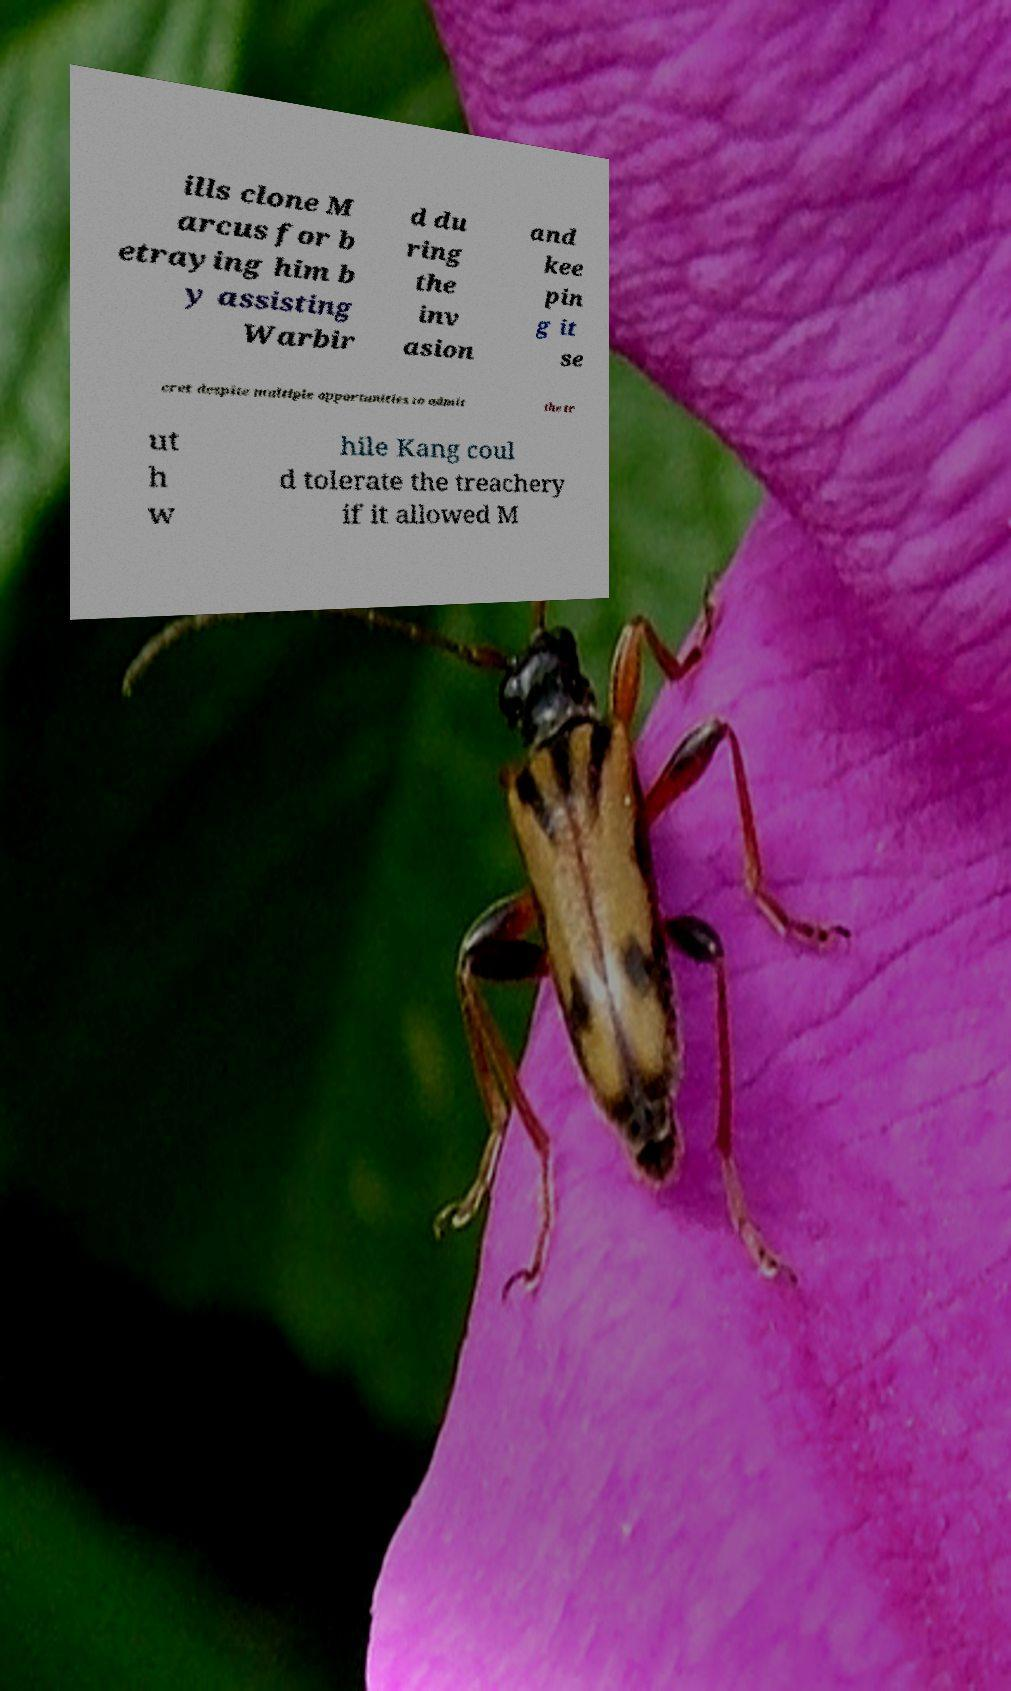Please identify and transcribe the text found in this image. ills clone M arcus for b etraying him b y assisting Warbir d du ring the inv asion and kee pin g it se cret despite multiple opportunities to admit the tr ut h w hile Kang coul d tolerate the treachery if it allowed M 